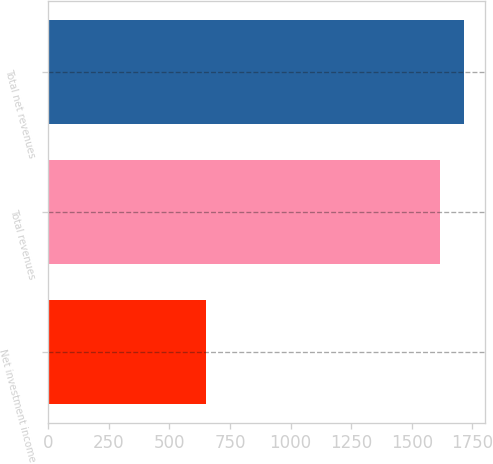Convert chart. <chart><loc_0><loc_0><loc_500><loc_500><bar_chart><fcel>Net investment income<fcel>Total revenues<fcel>Total net revenues<nl><fcel>652<fcel>1618<fcel>1714.6<nl></chart> 